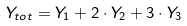Convert formula to latex. <formula><loc_0><loc_0><loc_500><loc_500>Y _ { t o t } = Y _ { 1 } + 2 \cdot Y _ { 2 } + 3 \cdot Y _ { 3 }</formula> 